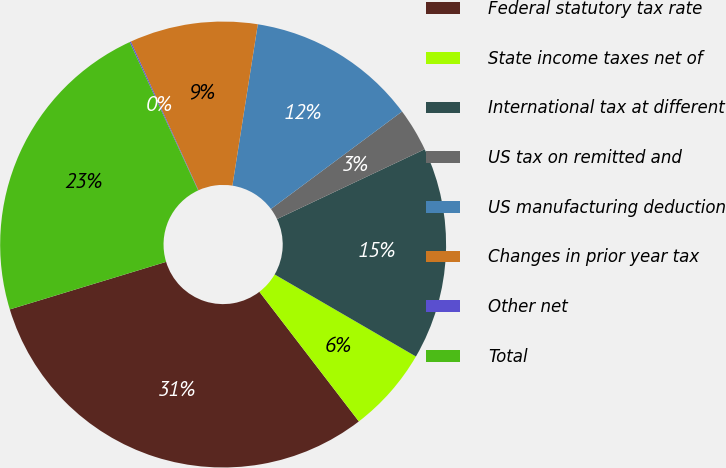<chart> <loc_0><loc_0><loc_500><loc_500><pie_chart><fcel>Federal statutory tax rate<fcel>State income taxes net of<fcel>International tax at different<fcel>US tax on remitted and<fcel>US manufacturing deduction<fcel>Changes in prior year tax<fcel>Other net<fcel>Total<nl><fcel>30.72%<fcel>6.21%<fcel>15.4%<fcel>3.15%<fcel>12.34%<fcel>9.28%<fcel>0.09%<fcel>22.82%<nl></chart> 